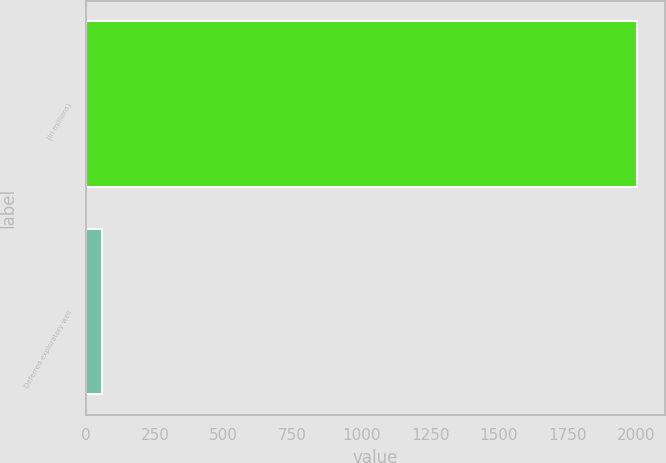<chart> <loc_0><loc_0><loc_500><loc_500><bar_chart><fcel>(In millions)<fcel>Deferred exploratory well<nl><fcel>2002<fcel>57<nl></chart> 